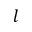<formula> <loc_0><loc_0><loc_500><loc_500>l</formula> 